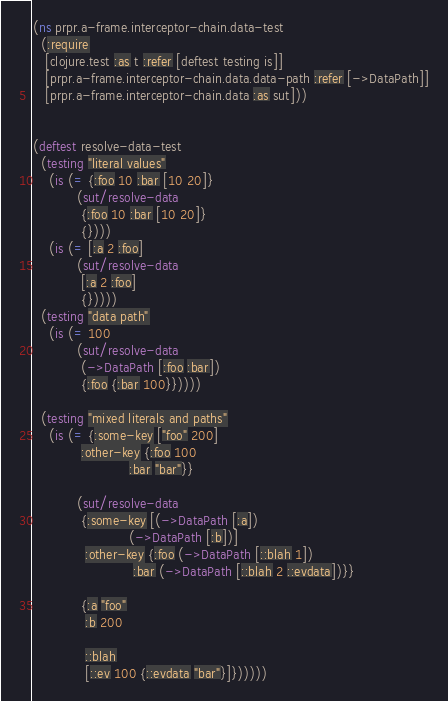<code> <loc_0><loc_0><loc_500><loc_500><_Clojure_>(ns prpr.a-frame.interceptor-chain.data-test
  (:require
   [clojure.test :as t :refer [deftest testing is]]
   [prpr.a-frame.interceptor-chain.data.data-path :refer [->DataPath]]
   [prpr.a-frame.interceptor-chain.data :as sut]))


(deftest resolve-data-test
  (testing "literal values"
    (is (= {:foo 10 :bar [10 20]}
           (sut/resolve-data
            {:foo 10 :bar [10 20]}
            {})))
    (is (= [:a 2 :foo]
           (sut/resolve-data
            [:a 2 :foo]
            {}))))
  (testing "data path"
    (is (= 100
           (sut/resolve-data
            (->DataPath [:foo :bar])
            {:foo {:bar 100}}))))

  (testing "mixed literals and paths"
    (is (= {:some-key ["foo" 200]
            :other-key {:foo 100
                        :bar "bar"}}

           (sut/resolve-data
            {:some-key [(->DataPath [:a])
                        (->DataPath [:b])]
             :other-key {:foo (->DataPath [::blah 1])
                         :bar (->DataPath [::blah 2 ::evdata])}}

            {:a "foo"
             :b 200

             ::blah
             [::ev 100 {::evdata "bar"}]})))))
</code> 